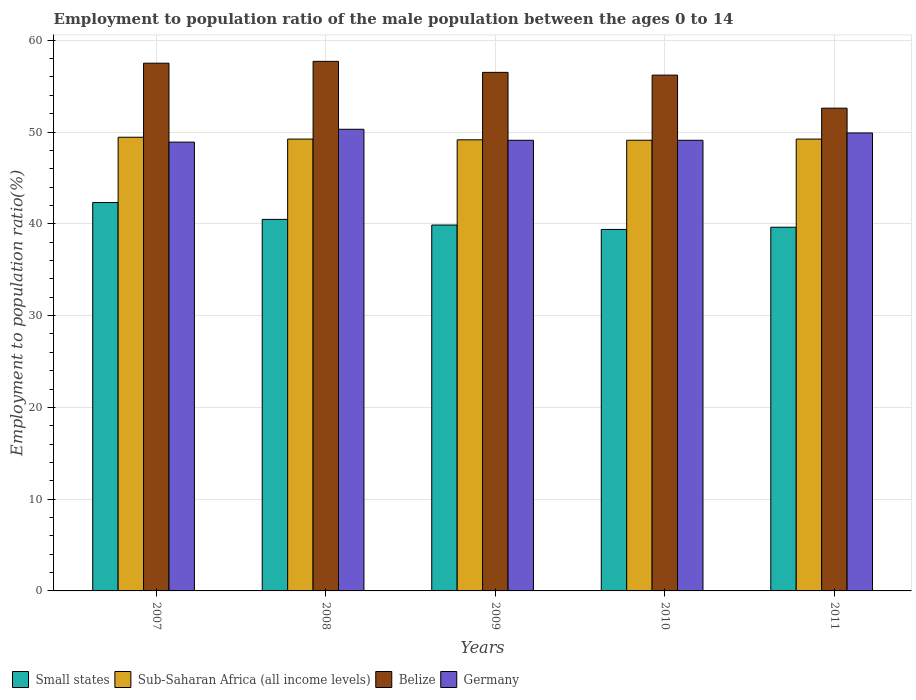How many different coloured bars are there?
Provide a short and direct response. 4. Are the number of bars per tick equal to the number of legend labels?
Provide a short and direct response. Yes. Are the number of bars on each tick of the X-axis equal?
Provide a short and direct response. Yes. What is the label of the 4th group of bars from the left?
Provide a short and direct response. 2010. What is the employment to population ratio in Belize in 2008?
Provide a succinct answer. 57.7. Across all years, what is the maximum employment to population ratio in Germany?
Your answer should be very brief. 50.3. Across all years, what is the minimum employment to population ratio in Sub-Saharan Africa (all income levels)?
Your answer should be compact. 49.11. In which year was the employment to population ratio in Belize minimum?
Give a very brief answer. 2011. What is the total employment to population ratio in Germany in the graph?
Offer a terse response. 247.3. What is the difference between the employment to population ratio in Sub-Saharan Africa (all income levels) in 2008 and that in 2011?
Give a very brief answer. 0. What is the difference between the employment to population ratio in Germany in 2007 and the employment to population ratio in Small states in 2010?
Keep it short and to the point. 9.51. What is the average employment to population ratio in Belize per year?
Offer a very short reply. 56.1. In the year 2009, what is the difference between the employment to population ratio in Belize and employment to population ratio in Germany?
Your answer should be compact. 7.4. In how many years, is the employment to population ratio in Belize greater than 2 %?
Your answer should be very brief. 5. What is the ratio of the employment to population ratio in Small states in 2008 to that in 2011?
Make the answer very short. 1.02. What is the difference between the highest and the second highest employment to population ratio in Belize?
Ensure brevity in your answer.  0.2. What is the difference between the highest and the lowest employment to population ratio in Germany?
Give a very brief answer. 1.4. Is it the case that in every year, the sum of the employment to population ratio in Germany and employment to population ratio in Small states is greater than the sum of employment to population ratio in Belize and employment to population ratio in Sub-Saharan Africa (all income levels)?
Your answer should be very brief. No. What does the 1st bar from the left in 2011 represents?
Make the answer very short. Small states. How many years are there in the graph?
Your response must be concise. 5. What is the difference between two consecutive major ticks on the Y-axis?
Make the answer very short. 10. Does the graph contain grids?
Give a very brief answer. Yes. What is the title of the graph?
Ensure brevity in your answer.  Employment to population ratio of the male population between the ages 0 to 14. What is the label or title of the X-axis?
Offer a terse response. Years. What is the Employment to population ratio(%) in Small states in 2007?
Offer a very short reply. 42.32. What is the Employment to population ratio(%) in Sub-Saharan Africa (all income levels) in 2007?
Ensure brevity in your answer.  49.43. What is the Employment to population ratio(%) in Belize in 2007?
Give a very brief answer. 57.5. What is the Employment to population ratio(%) in Germany in 2007?
Give a very brief answer. 48.9. What is the Employment to population ratio(%) of Small states in 2008?
Your answer should be compact. 40.48. What is the Employment to population ratio(%) of Sub-Saharan Africa (all income levels) in 2008?
Offer a terse response. 49.23. What is the Employment to population ratio(%) of Belize in 2008?
Keep it short and to the point. 57.7. What is the Employment to population ratio(%) of Germany in 2008?
Provide a succinct answer. 50.3. What is the Employment to population ratio(%) in Small states in 2009?
Keep it short and to the point. 39.87. What is the Employment to population ratio(%) of Sub-Saharan Africa (all income levels) in 2009?
Provide a succinct answer. 49.15. What is the Employment to population ratio(%) in Belize in 2009?
Your answer should be compact. 56.5. What is the Employment to population ratio(%) in Germany in 2009?
Give a very brief answer. 49.1. What is the Employment to population ratio(%) of Small states in 2010?
Provide a succinct answer. 39.39. What is the Employment to population ratio(%) of Sub-Saharan Africa (all income levels) in 2010?
Provide a short and direct response. 49.11. What is the Employment to population ratio(%) of Belize in 2010?
Ensure brevity in your answer.  56.2. What is the Employment to population ratio(%) of Germany in 2010?
Offer a very short reply. 49.1. What is the Employment to population ratio(%) of Small states in 2011?
Your answer should be very brief. 39.63. What is the Employment to population ratio(%) in Sub-Saharan Africa (all income levels) in 2011?
Your answer should be very brief. 49.23. What is the Employment to population ratio(%) of Belize in 2011?
Keep it short and to the point. 52.6. What is the Employment to population ratio(%) in Germany in 2011?
Give a very brief answer. 49.9. Across all years, what is the maximum Employment to population ratio(%) of Small states?
Keep it short and to the point. 42.32. Across all years, what is the maximum Employment to population ratio(%) of Sub-Saharan Africa (all income levels)?
Offer a terse response. 49.43. Across all years, what is the maximum Employment to population ratio(%) in Belize?
Your response must be concise. 57.7. Across all years, what is the maximum Employment to population ratio(%) of Germany?
Ensure brevity in your answer.  50.3. Across all years, what is the minimum Employment to population ratio(%) in Small states?
Offer a terse response. 39.39. Across all years, what is the minimum Employment to population ratio(%) of Sub-Saharan Africa (all income levels)?
Your response must be concise. 49.11. Across all years, what is the minimum Employment to population ratio(%) in Belize?
Offer a terse response. 52.6. Across all years, what is the minimum Employment to population ratio(%) of Germany?
Offer a terse response. 48.9. What is the total Employment to population ratio(%) of Small states in the graph?
Your answer should be compact. 201.68. What is the total Employment to population ratio(%) in Sub-Saharan Africa (all income levels) in the graph?
Provide a short and direct response. 246.15. What is the total Employment to population ratio(%) of Belize in the graph?
Offer a very short reply. 280.5. What is the total Employment to population ratio(%) in Germany in the graph?
Provide a succinct answer. 247.3. What is the difference between the Employment to population ratio(%) in Small states in 2007 and that in 2008?
Provide a short and direct response. 1.84. What is the difference between the Employment to population ratio(%) in Sub-Saharan Africa (all income levels) in 2007 and that in 2008?
Give a very brief answer. 0.2. What is the difference between the Employment to population ratio(%) of Belize in 2007 and that in 2008?
Provide a short and direct response. -0.2. What is the difference between the Employment to population ratio(%) of Small states in 2007 and that in 2009?
Your response must be concise. 2.45. What is the difference between the Employment to population ratio(%) in Sub-Saharan Africa (all income levels) in 2007 and that in 2009?
Your response must be concise. 0.28. What is the difference between the Employment to population ratio(%) in Belize in 2007 and that in 2009?
Provide a succinct answer. 1. What is the difference between the Employment to population ratio(%) in Small states in 2007 and that in 2010?
Provide a short and direct response. 2.94. What is the difference between the Employment to population ratio(%) of Sub-Saharan Africa (all income levels) in 2007 and that in 2010?
Ensure brevity in your answer.  0.33. What is the difference between the Employment to population ratio(%) in Small states in 2007 and that in 2011?
Provide a succinct answer. 2.69. What is the difference between the Employment to population ratio(%) in Sub-Saharan Africa (all income levels) in 2007 and that in 2011?
Provide a short and direct response. 0.2. What is the difference between the Employment to population ratio(%) in Germany in 2007 and that in 2011?
Offer a terse response. -1. What is the difference between the Employment to population ratio(%) in Small states in 2008 and that in 2009?
Give a very brief answer. 0.61. What is the difference between the Employment to population ratio(%) of Sub-Saharan Africa (all income levels) in 2008 and that in 2009?
Provide a short and direct response. 0.08. What is the difference between the Employment to population ratio(%) in Belize in 2008 and that in 2009?
Your response must be concise. 1.2. What is the difference between the Employment to population ratio(%) in Germany in 2008 and that in 2009?
Your answer should be compact. 1.2. What is the difference between the Employment to population ratio(%) in Small states in 2008 and that in 2010?
Give a very brief answer. 1.1. What is the difference between the Employment to population ratio(%) of Sub-Saharan Africa (all income levels) in 2008 and that in 2010?
Your answer should be very brief. 0.13. What is the difference between the Employment to population ratio(%) in Belize in 2008 and that in 2010?
Provide a succinct answer. 1.5. What is the difference between the Employment to population ratio(%) of Small states in 2008 and that in 2011?
Give a very brief answer. 0.86. What is the difference between the Employment to population ratio(%) in Belize in 2008 and that in 2011?
Make the answer very short. 5.1. What is the difference between the Employment to population ratio(%) of Germany in 2008 and that in 2011?
Keep it short and to the point. 0.4. What is the difference between the Employment to population ratio(%) in Small states in 2009 and that in 2010?
Keep it short and to the point. 0.48. What is the difference between the Employment to population ratio(%) in Sub-Saharan Africa (all income levels) in 2009 and that in 2010?
Your response must be concise. 0.05. What is the difference between the Employment to population ratio(%) of Belize in 2009 and that in 2010?
Provide a short and direct response. 0.3. What is the difference between the Employment to population ratio(%) in Small states in 2009 and that in 2011?
Your answer should be very brief. 0.24. What is the difference between the Employment to population ratio(%) of Sub-Saharan Africa (all income levels) in 2009 and that in 2011?
Your response must be concise. -0.08. What is the difference between the Employment to population ratio(%) in Belize in 2009 and that in 2011?
Your answer should be very brief. 3.9. What is the difference between the Employment to population ratio(%) of Small states in 2010 and that in 2011?
Make the answer very short. -0.24. What is the difference between the Employment to population ratio(%) in Sub-Saharan Africa (all income levels) in 2010 and that in 2011?
Offer a terse response. -0.13. What is the difference between the Employment to population ratio(%) in Small states in 2007 and the Employment to population ratio(%) in Sub-Saharan Africa (all income levels) in 2008?
Provide a succinct answer. -6.91. What is the difference between the Employment to population ratio(%) in Small states in 2007 and the Employment to population ratio(%) in Belize in 2008?
Ensure brevity in your answer.  -15.38. What is the difference between the Employment to population ratio(%) in Small states in 2007 and the Employment to population ratio(%) in Germany in 2008?
Keep it short and to the point. -7.98. What is the difference between the Employment to population ratio(%) of Sub-Saharan Africa (all income levels) in 2007 and the Employment to population ratio(%) of Belize in 2008?
Your response must be concise. -8.27. What is the difference between the Employment to population ratio(%) of Sub-Saharan Africa (all income levels) in 2007 and the Employment to population ratio(%) of Germany in 2008?
Your answer should be very brief. -0.87. What is the difference between the Employment to population ratio(%) of Small states in 2007 and the Employment to population ratio(%) of Sub-Saharan Africa (all income levels) in 2009?
Ensure brevity in your answer.  -6.83. What is the difference between the Employment to population ratio(%) in Small states in 2007 and the Employment to population ratio(%) in Belize in 2009?
Offer a terse response. -14.18. What is the difference between the Employment to population ratio(%) of Small states in 2007 and the Employment to population ratio(%) of Germany in 2009?
Offer a very short reply. -6.78. What is the difference between the Employment to population ratio(%) of Sub-Saharan Africa (all income levels) in 2007 and the Employment to population ratio(%) of Belize in 2009?
Make the answer very short. -7.07. What is the difference between the Employment to population ratio(%) in Sub-Saharan Africa (all income levels) in 2007 and the Employment to population ratio(%) in Germany in 2009?
Your response must be concise. 0.33. What is the difference between the Employment to population ratio(%) of Small states in 2007 and the Employment to population ratio(%) of Sub-Saharan Africa (all income levels) in 2010?
Offer a very short reply. -6.78. What is the difference between the Employment to population ratio(%) in Small states in 2007 and the Employment to population ratio(%) in Belize in 2010?
Provide a short and direct response. -13.88. What is the difference between the Employment to population ratio(%) of Small states in 2007 and the Employment to population ratio(%) of Germany in 2010?
Offer a terse response. -6.78. What is the difference between the Employment to population ratio(%) of Sub-Saharan Africa (all income levels) in 2007 and the Employment to population ratio(%) of Belize in 2010?
Keep it short and to the point. -6.77. What is the difference between the Employment to population ratio(%) in Sub-Saharan Africa (all income levels) in 2007 and the Employment to population ratio(%) in Germany in 2010?
Offer a terse response. 0.33. What is the difference between the Employment to population ratio(%) of Small states in 2007 and the Employment to population ratio(%) of Sub-Saharan Africa (all income levels) in 2011?
Provide a short and direct response. -6.91. What is the difference between the Employment to population ratio(%) in Small states in 2007 and the Employment to population ratio(%) in Belize in 2011?
Your answer should be compact. -10.28. What is the difference between the Employment to population ratio(%) in Small states in 2007 and the Employment to population ratio(%) in Germany in 2011?
Provide a short and direct response. -7.58. What is the difference between the Employment to population ratio(%) in Sub-Saharan Africa (all income levels) in 2007 and the Employment to population ratio(%) in Belize in 2011?
Ensure brevity in your answer.  -3.17. What is the difference between the Employment to population ratio(%) in Sub-Saharan Africa (all income levels) in 2007 and the Employment to population ratio(%) in Germany in 2011?
Offer a very short reply. -0.47. What is the difference between the Employment to population ratio(%) in Small states in 2008 and the Employment to population ratio(%) in Sub-Saharan Africa (all income levels) in 2009?
Make the answer very short. -8.67. What is the difference between the Employment to population ratio(%) of Small states in 2008 and the Employment to population ratio(%) of Belize in 2009?
Keep it short and to the point. -16.02. What is the difference between the Employment to population ratio(%) of Small states in 2008 and the Employment to population ratio(%) of Germany in 2009?
Keep it short and to the point. -8.62. What is the difference between the Employment to population ratio(%) of Sub-Saharan Africa (all income levels) in 2008 and the Employment to population ratio(%) of Belize in 2009?
Offer a terse response. -7.27. What is the difference between the Employment to population ratio(%) in Sub-Saharan Africa (all income levels) in 2008 and the Employment to population ratio(%) in Germany in 2009?
Your answer should be compact. 0.13. What is the difference between the Employment to population ratio(%) in Belize in 2008 and the Employment to population ratio(%) in Germany in 2009?
Offer a terse response. 8.6. What is the difference between the Employment to population ratio(%) in Small states in 2008 and the Employment to population ratio(%) in Sub-Saharan Africa (all income levels) in 2010?
Offer a terse response. -8.62. What is the difference between the Employment to population ratio(%) of Small states in 2008 and the Employment to population ratio(%) of Belize in 2010?
Ensure brevity in your answer.  -15.72. What is the difference between the Employment to population ratio(%) in Small states in 2008 and the Employment to population ratio(%) in Germany in 2010?
Offer a terse response. -8.62. What is the difference between the Employment to population ratio(%) of Sub-Saharan Africa (all income levels) in 2008 and the Employment to population ratio(%) of Belize in 2010?
Give a very brief answer. -6.97. What is the difference between the Employment to population ratio(%) in Sub-Saharan Africa (all income levels) in 2008 and the Employment to population ratio(%) in Germany in 2010?
Ensure brevity in your answer.  0.13. What is the difference between the Employment to population ratio(%) of Small states in 2008 and the Employment to population ratio(%) of Sub-Saharan Africa (all income levels) in 2011?
Offer a terse response. -8.75. What is the difference between the Employment to population ratio(%) in Small states in 2008 and the Employment to population ratio(%) in Belize in 2011?
Your answer should be very brief. -12.12. What is the difference between the Employment to population ratio(%) of Small states in 2008 and the Employment to population ratio(%) of Germany in 2011?
Give a very brief answer. -9.42. What is the difference between the Employment to population ratio(%) in Sub-Saharan Africa (all income levels) in 2008 and the Employment to population ratio(%) in Belize in 2011?
Provide a short and direct response. -3.37. What is the difference between the Employment to population ratio(%) of Sub-Saharan Africa (all income levels) in 2008 and the Employment to population ratio(%) of Germany in 2011?
Ensure brevity in your answer.  -0.67. What is the difference between the Employment to population ratio(%) of Small states in 2009 and the Employment to population ratio(%) of Sub-Saharan Africa (all income levels) in 2010?
Offer a terse response. -9.24. What is the difference between the Employment to population ratio(%) of Small states in 2009 and the Employment to population ratio(%) of Belize in 2010?
Your answer should be very brief. -16.33. What is the difference between the Employment to population ratio(%) of Small states in 2009 and the Employment to population ratio(%) of Germany in 2010?
Keep it short and to the point. -9.23. What is the difference between the Employment to population ratio(%) of Sub-Saharan Africa (all income levels) in 2009 and the Employment to population ratio(%) of Belize in 2010?
Your answer should be compact. -7.05. What is the difference between the Employment to population ratio(%) in Sub-Saharan Africa (all income levels) in 2009 and the Employment to population ratio(%) in Germany in 2010?
Provide a short and direct response. 0.05. What is the difference between the Employment to population ratio(%) of Belize in 2009 and the Employment to population ratio(%) of Germany in 2010?
Your response must be concise. 7.4. What is the difference between the Employment to population ratio(%) in Small states in 2009 and the Employment to population ratio(%) in Sub-Saharan Africa (all income levels) in 2011?
Keep it short and to the point. -9.36. What is the difference between the Employment to population ratio(%) of Small states in 2009 and the Employment to population ratio(%) of Belize in 2011?
Offer a very short reply. -12.73. What is the difference between the Employment to population ratio(%) in Small states in 2009 and the Employment to population ratio(%) in Germany in 2011?
Provide a short and direct response. -10.03. What is the difference between the Employment to population ratio(%) of Sub-Saharan Africa (all income levels) in 2009 and the Employment to population ratio(%) of Belize in 2011?
Offer a terse response. -3.45. What is the difference between the Employment to population ratio(%) in Sub-Saharan Africa (all income levels) in 2009 and the Employment to population ratio(%) in Germany in 2011?
Provide a succinct answer. -0.75. What is the difference between the Employment to population ratio(%) in Small states in 2010 and the Employment to population ratio(%) in Sub-Saharan Africa (all income levels) in 2011?
Provide a short and direct response. -9.85. What is the difference between the Employment to population ratio(%) in Small states in 2010 and the Employment to population ratio(%) in Belize in 2011?
Make the answer very short. -13.21. What is the difference between the Employment to population ratio(%) in Small states in 2010 and the Employment to population ratio(%) in Germany in 2011?
Ensure brevity in your answer.  -10.51. What is the difference between the Employment to population ratio(%) in Sub-Saharan Africa (all income levels) in 2010 and the Employment to population ratio(%) in Belize in 2011?
Provide a succinct answer. -3.49. What is the difference between the Employment to population ratio(%) in Sub-Saharan Africa (all income levels) in 2010 and the Employment to population ratio(%) in Germany in 2011?
Ensure brevity in your answer.  -0.79. What is the average Employment to population ratio(%) in Small states per year?
Your answer should be compact. 40.34. What is the average Employment to population ratio(%) in Sub-Saharan Africa (all income levels) per year?
Ensure brevity in your answer.  49.23. What is the average Employment to population ratio(%) in Belize per year?
Provide a succinct answer. 56.1. What is the average Employment to population ratio(%) in Germany per year?
Make the answer very short. 49.46. In the year 2007, what is the difference between the Employment to population ratio(%) of Small states and Employment to population ratio(%) of Sub-Saharan Africa (all income levels)?
Your answer should be compact. -7.11. In the year 2007, what is the difference between the Employment to population ratio(%) of Small states and Employment to population ratio(%) of Belize?
Your response must be concise. -15.18. In the year 2007, what is the difference between the Employment to population ratio(%) in Small states and Employment to population ratio(%) in Germany?
Provide a short and direct response. -6.58. In the year 2007, what is the difference between the Employment to population ratio(%) of Sub-Saharan Africa (all income levels) and Employment to population ratio(%) of Belize?
Give a very brief answer. -8.07. In the year 2007, what is the difference between the Employment to population ratio(%) of Sub-Saharan Africa (all income levels) and Employment to population ratio(%) of Germany?
Provide a short and direct response. 0.53. In the year 2007, what is the difference between the Employment to population ratio(%) in Belize and Employment to population ratio(%) in Germany?
Offer a terse response. 8.6. In the year 2008, what is the difference between the Employment to population ratio(%) of Small states and Employment to population ratio(%) of Sub-Saharan Africa (all income levels)?
Ensure brevity in your answer.  -8.75. In the year 2008, what is the difference between the Employment to population ratio(%) in Small states and Employment to population ratio(%) in Belize?
Keep it short and to the point. -17.22. In the year 2008, what is the difference between the Employment to population ratio(%) in Small states and Employment to population ratio(%) in Germany?
Offer a terse response. -9.82. In the year 2008, what is the difference between the Employment to population ratio(%) of Sub-Saharan Africa (all income levels) and Employment to population ratio(%) of Belize?
Provide a succinct answer. -8.47. In the year 2008, what is the difference between the Employment to population ratio(%) of Sub-Saharan Africa (all income levels) and Employment to population ratio(%) of Germany?
Offer a terse response. -1.07. In the year 2009, what is the difference between the Employment to population ratio(%) of Small states and Employment to population ratio(%) of Sub-Saharan Africa (all income levels)?
Offer a very short reply. -9.28. In the year 2009, what is the difference between the Employment to population ratio(%) in Small states and Employment to population ratio(%) in Belize?
Offer a very short reply. -16.63. In the year 2009, what is the difference between the Employment to population ratio(%) of Small states and Employment to population ratio(%) of Germany?
Your response must be concise. -9.23. In the year 2009, what is the difference between the Employment to population ratio(%) in Sub-Saharan Africa (all income levels) and Employment to population ratio(%) in Belize?
Provide a succinct answer. -7.35. In the year 2009, what is the difference between the Employment to population ratio(%) in Sub-Saharan Africa (all income levels) and Employment to population ratio(%) in Germany?
Your response must be concise. 0.05. In the year 2009, what is the difference between the Employment to population ratio(%) in Belize and Employment to population ratio(%) in Germany?
Provide a succinct answer. 7.4. In the year 2010, what is the difference between the Employment to population ratio(%) of Small states and Employment to population ratio(%) of Sub-Saharan Africa (all income levels)?
Provide a succinct answer. -9.72. In the year 2010, what is the difference between the Employment to population ratio(%) of Small states and Employment to population ratio(%) of Belize?
Your answer should be very brief. -16.81. In the year 2010, what is the difference between the Employment to population ratio(%) in Small states and Employment to population ratio(%) in Germany?
Give a very brief answer. -9.71. In the year 2010, what is the difference between the Employment to population ratio(%) in Sub-Saharan Africa (all income levels) and Employment to population ratio(%) in Belize?
Make the answer very short. -7.09. In the year 2010, what is the difference between the Employment to population ratio(%) in Sub-Saharan Africa (all income levels) and Employment to population ratio(%) in Germany?
Keep it short and to the point. 0.01. In the year 2010, what is the difference between the Employment to population ratio(%) in Belize and Employment to population ratio(%) in Germany?
Offer a terse response. 7.1. In the year 2011, what is the difference between the Employment to population ratio(%) of Small states and Employment to population ratio(%) of Sub-Saharan Africa (all income levels)?
Your response must be concise. -9.6. In the year 2011, what is the difference between the Employment to population ratio(%) in Small states and Employment to population ratio(%) in Belize?
Offer a very short reply. -12.97. In the year 2011, what is the difference between the Employment to population ratio(%) in Small states and Employment to population ratio(%) in Germany?
Give a very brief answer. -10.27. In the year 2011, what is the difference between the Employment to population ratio(%) in Sub-Saharan Africa (all income levels) and Employment to population ratio(%) in Belize?
Your response must be concise. -3.37. In the year 2011, what is the difference between the Employment to population ratio(%) in Sub-Saharan Africa (all income levels) and Employment to population ratio(%) in Germany?
Provide a short and direct response. -0.67. What is the ratio of the Employment to population ratio(%) of Small states in 2007 to that in 2008?
Your answer should be very brief. 1.05. What is the ratio of the Employment to population ratio(%) of Belize in 2007 to that in 2008?
Provide a succinct answer. 1. What is the ratio of the Employment to population ratio(%) of Germany in 2007 to that in 2008?
Ensure brevity in your answer.  0.97. What is the ratio of the Employment to population ratio(%) in Small states in 2007 to that in 2009?
Offer a terse response. 1.06. What is the ratio of the Employment to population ratio(%) in Sub-Saharan Africa (all income levels) in 2007 to that in 2009?
Give a very brief answer. 1.01. What is the ratio of the Employment to population ratio(%) in Belize in 2007 to that in 2009?
Make the answer very short. 1.02. What is the ratio of the Employment to population ratio(%) in Germany in 2007 to that in 2009?
Keep it short and to the point. 1. What is the ratio of the Employment to population ratio(%) in Small states in 2007 to that in 2010?
Offer a terse response. 1.07. What is the ratio of the Employment to population ratio(%) in Sub-Saharan Africa (all income levels) in 2007 to that in 2010?
Provide a succinct answer. 1.01. What is the ratio of the Employment to population ratio(%) of Belize in 2007 to that in 2010?
Keep it short and to the point. 1.02. What is the ratio of the Employment to population ratio(%) in Small states in 2007 to that in 2011?
Your answer should be compact. 1.07. What is the ratio of the Employment to population ratio(%) of Sub-Saharan Africa (all income levels) in 2007 to that in 2011?
Your answer should be very brief. 1. What is the ratio of the Employment to population ratio(%) in Belize in 2007 to that in 2011?
Your response must be concise. 1.09. What is the ratio of the Employment to population ratio(%) of Small states in 2008 to that in 2009?
Ensure brevity in your answer.  1.02. What is the ratio of the Employment to population ratio(%) of Sub-Saharan Africa (all income levels) in 2008 to that in 2009?
Offer a very short reply. 1. What is the ratio of the Employment to population ratio(%) of Belize in 2008 to that in 2009?
Provide a succinct answer. 1.02. What is the ratio of the Employment to population ratio(%) of Germany in 2008 to that in 2009?
Offer a very short reply. 1.02. What is the ratio of the Employment to population ratio(%) in Small states in 2008 to that in 2010?
Your response must be concise. 1.03. What is the ratio of the Employment to population ratio(%) of Belize in 2008 to that in 2010?
Your answer should be compact. 1.03. What is the ratio of the Employment to population ratio(%) in Germany in 2008 to that in 2010?
Offer a terse response. 1.02. What is the ratio of the Employment to population ratio(%) in Small states in 2008 to that in 2011?
Offer a very short reply. 1.02. What is the ratio of the Employment to population ratio(%) in Belize in 2008 to that in 2011?
Keep it short and to the point. 1.1. What is the ratio of the Employment to population ratio(%) of Germany in 2008 to that in 2011?
Your answer should be very brief. 1.01. What is the ratio of the Employment to population ratio(%) of Small states in 2009 to that in 2010?
Ensure brevity in your answer.  1.01. What is the ratio of the Employment to population ratio(%) in Sub-Saharan Africa (all income levels) in 2009 to that in 2010?
Keep it short and to the point. 1. What is the ratio of the Employment to population ratio(%) of Belize in 2009 to that in 2010?
Your answer should be compact. 1.01. What is the ratio of the Employment to population ratio(%) in Germany in 2009 to that in 2010?
Keep it short and to the point. 1. What is the ratio of the Employment to population ratio(%) in Small states in 2009 to that in 2011?
Your answer should be compact. 1.01. What is the ratio of the Employment to population ratio(%) in Belize in 2009 to that in 2011?
Keep it short and to the point. 1.07. What is the ratio of the Employment to population ratio(%) in Germany in 2009 to that in 2011?
Your response must be concise. 0.98. What is the ratio of the Employment to population ratio(%) in Belize in 2010 to that in 2011?
Offer a terse response. 1.07. What is the difference between the highest and the second highest Employment to population ratio(%) in Small states?
Your answer should be very brief. 1.84. What is the difference between the highest and the second highest Employment to population ratio(%) in Sub-Saharan Africa (all income levels)?
Provide a short and direct response. 0.2. What is the difference between the highest and the lowest Employment to population ratio(%) of Small states?
Your answer should be compact. 2.94. What is the difference between the highest and the lowest Employment to population ratio(%) in Sub-Saharan Africa (all income levels)?
Ensure brevity in your answer.  0.33. What is the difference between the highest and the lowest Employment to population ratio(%) in Belize?
Keep it short and to the point. 5.1. 